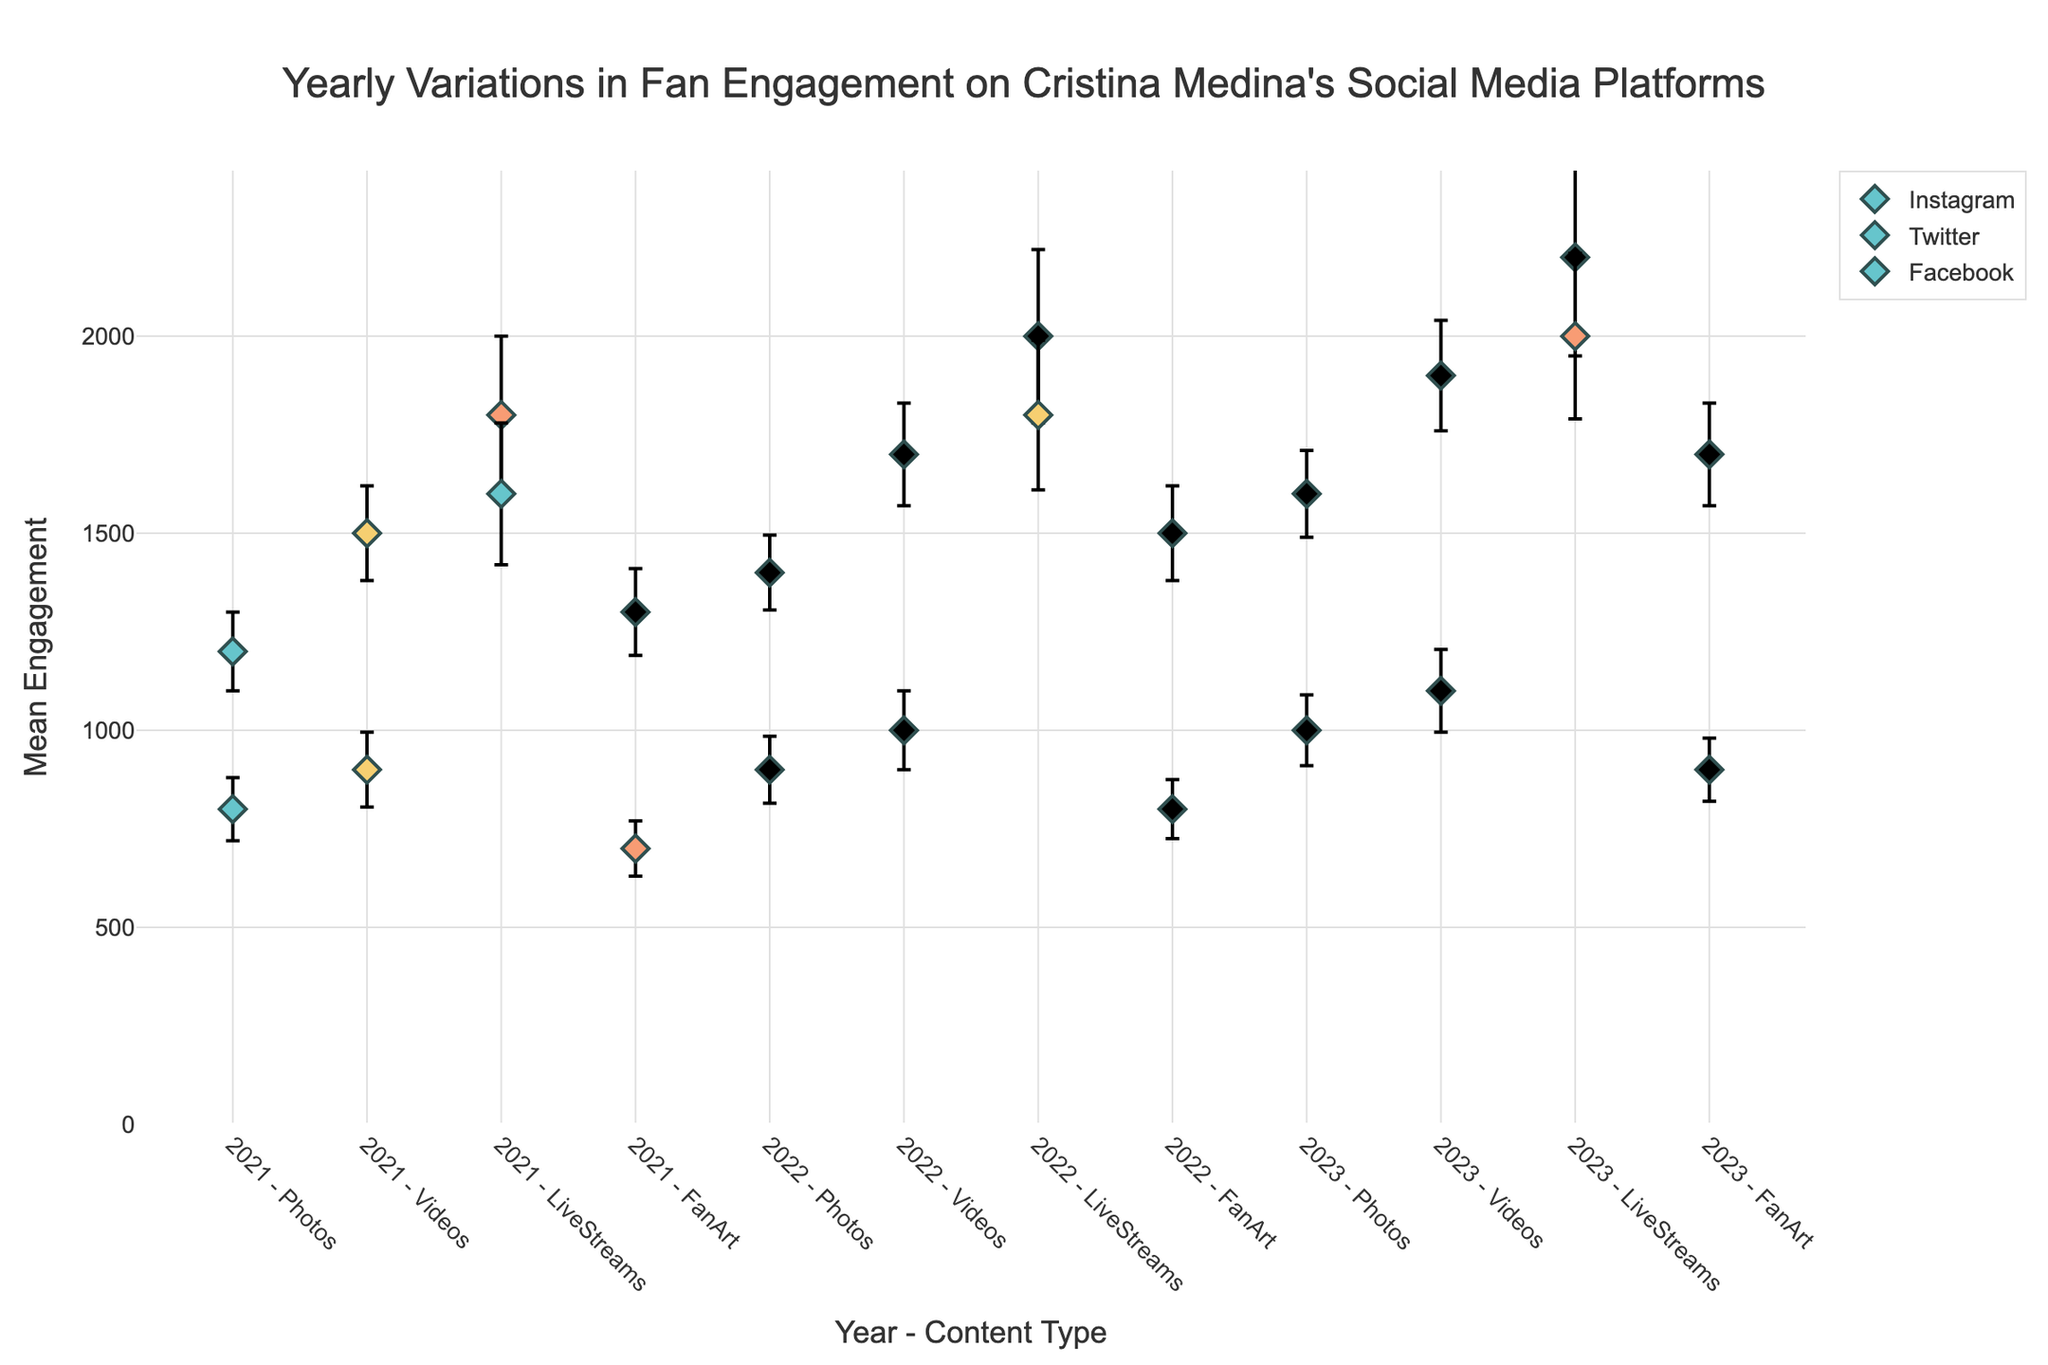What's the title of the plot? The title of the plot is usually found at the top of the figure. In this case, it is "Yearly Variations in Fan Engagement on Cristina Medina's Social Media Platforms."
Answer: Yearly Variations in Fan Engagement on Cristina Medina's Social Media Platforms Which platform had the highest mean engagement for live streams in 2023? To find this, look at the y-axis values for the live streams category in 2023 and compare the platforms. Instagram has a higher value compared to Facebook.
Answer: Instagram What was the mean engagement for videos on Twitter in 2022? Find the marker for the year 2022, content type 'Videos' on the x-axis, and check the corresponding y-value that represents Twitter's mean engagement.
Answer: 1000 Which content type on Instagram showed the most significant increase in mean engagement from 2021 to 2023? Compare the y-values (mean engagement) for Instagram across 2021 to 2023 for each content type. LiveStreams show the most significant increase from 1800 in 2021 to 2200 in 2023.
Answer: LiveStreams How does the error margin for photos on Twitter in 2023 compare to that in 2021? To compare error margins, look at the error bars for photos on Twitter in both years. In 2021, the error is 80; in 2023, the error is 90. Thus, the error margin increased.
Answer: Higher in 2023 Calculate the difference between the mean engagement of fan art on Instagram in 2021 and 2023. To find the difference, subtract the 2021 value from the 2023 value for the FanArt content type on Instagram. In 2021, it is 1300. In 2023, it is 1700. The difference is 1700 - 1300.
Answer: 400 For which content type did Instagram see the smallest increase in mean engagement from 2021 to 2023? Compare the increase in mean engagement for each content type on Instagram from 2021 to 2023. Photos increased from 1200 to 1600. FanArt increased from 1300 to 1700. Videos increased from 1500 to 1900. LiveStreams increased from 1800 to 2200. The smallest increase is for Photos.
Answer: Photos What was the mean engagement for LiveStreams on Facebook in 2022? Locate the marker for LiveStreams on Facebook for the year 2022 on the x-axis and find the corresponding y-value.
Answer: 1800 